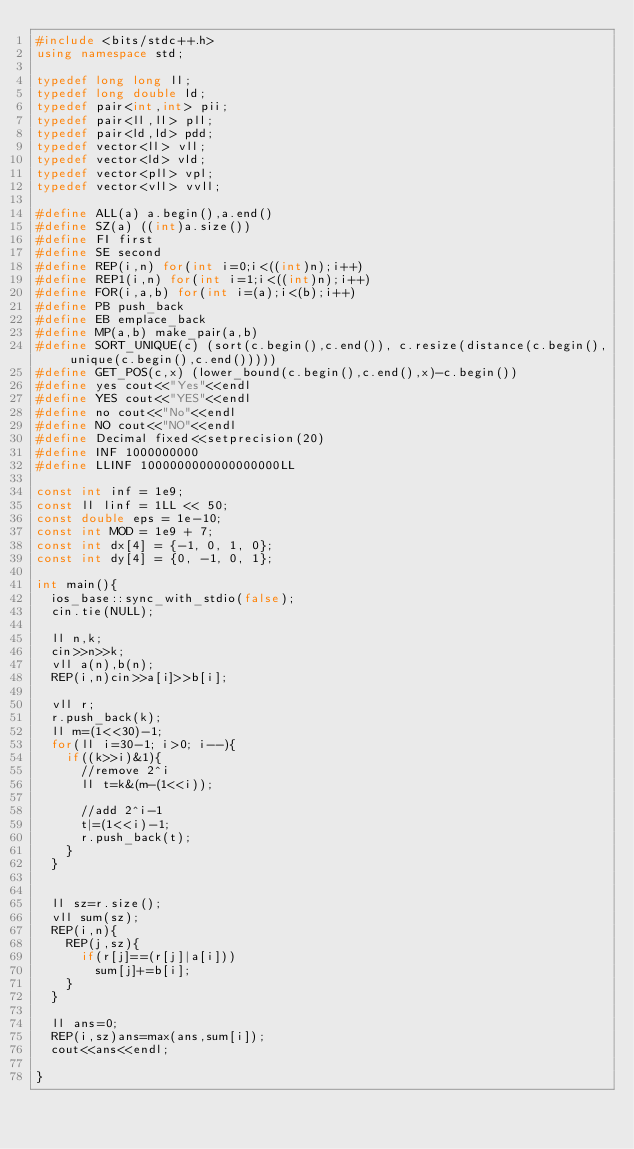Convert code to text. <code><loc_0><loc_0><loc_500><loc_500><_C++_>#include <bits/stdc++.h>
using namespace std;

typedef long long ll;
typedef long double ld;
typedef pair<int,int> pii;
typedef pair<ll,ll> pll;
typedef pair<ld,ld> pdd;
typedef vector<ll> vll;
typedef vector<ld> vld;
typedef vector<pll> vpl;
typedef vector<vll> vvll;

#define ALL(a) a.begin(),a.end()
#define SZ(a) ((int)a.size())
#define FI first
#define SE second
#define REP(i,n) for(int i=0;i<((int)n);i++)
#define REP1(i,n) for(int i=1;i<((int)n);i++)
#define FOR(i,a,b) for(int i=(a);i<(b);i++)
#define PB push_back
#define EB emplace_back
#define MP(a,b) make_pair(a,b)
#define SORT_UNIQUE(c) (sort(c.begin(),c.end()), c.resize(distance(c.begin(),unique(c.begin(),c.end()))))
#define GET_POS(c,x) (lower_bound(c.begin(),c.end(),x)-c.begin())
#define yes cout<<"Yes"<<endl
#define YES cout<<"YES"<<endl
#define no cout<<"No"<<endl
#define NO cout<<"NO"<<endl
#define Decimal fixed<<setprecision(20)
#define INF 1000000000
#define LLINF 1000000000000000000LL

const int inf = 1e9;
const ll linf = 1LL << 50;
const double eps = 1e-10;
const int MOD = 1e9 + 7;
const int dx[4] = {-1, 0, 1, 0};
const int dy[4] = {0, -1, 0, 1};

int main(){
  ios_base::sync_with_stdio(false);
  cin.tie(NULL);

  ll n,k;
  cin>>n>>k;
  vll a(n),b(n);
  REP(i,n)cin>>a[i]>>b[i];

  vll r;
  r.push_back(k);
  ll m=(1<<30)-1;
  for(ll i=30-1; i>0; i--){
    if((k>>i)&1){
      //remove 2^i
      ll t=k&(m-(1<<i));

      //add 2^i-1
      t|=(1<<i)-1;
      r.push_back(t);
    }
  }


  ll sz=r.size();
  vll sum(sz);
  REP(i,n){
    REP(j,sz){
      if(r[j]==(r[j]|a[i]))
        sum[j]+=b[i];
    }
  }

  ll ans=0;
  REP(i,sz)ans=max(ans,sum[i]);
  cout<<ans<<endl;

}

</code> 